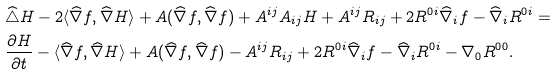<formula> <loc_0><loc_0><loc_500><loc_500>& \widehat { \triangle } H - 2 \langle \widehat { \nabla } f , \widehat { \nabla } H \rangle + A ( \widehat { \nabla } f , \widehat { \nabla } f ) + A ^ { i j } A _ { i j } H + A ^ { i j } R _ { i j } + 2 R ^ { 0 i } \widehat { \nabla } _ { i } f - \widehat { \nabla } _ { i } R ^ { 0 i } = \\ & \frac { \partial H } { \partial t } - \langle \widehat { \nabla } f , \widehat { \nabla } H \rangle + A ( \widehat { \nabla } f , \widehat { \nabla } f ) - A ^ { i j } R _ { i j } + 2 R ^ { 0 i } \widehat { \nabla } _ { i } f - \widehat { \nabla } _ { i } R ^ { 0 i } - \nabla _ { 0 } R ^ { 0 0 } .</formula> 